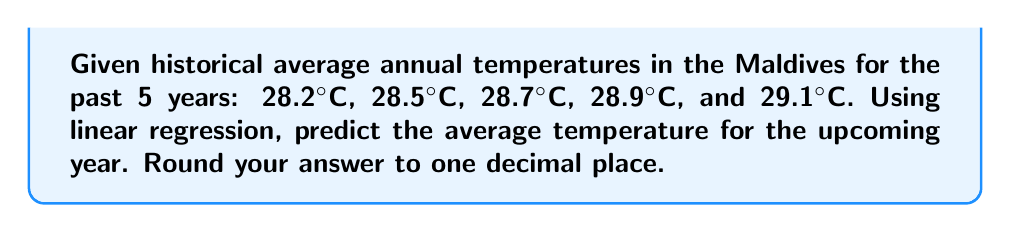Can you answer this question? To predict the future temperature using linear regression, we'll follow these steps:

1. Assign x-values to each year (1, 2, 3, 4, 5) and y-values to the corresponding temperatures.

2. Calculate the means of x and y:
   $\bar{x} = \frac{1+2+3+4+5}{5} = 3$
   $\bar{y} = \frac{28.2+28.5+28.7+28.9+29.1}{5} = 28.68$

3. Calculate the slope (m) using the formula:
   $$m = \frac{\sum(x_i - \bar{x})(y_i - \bar{y})}{\sum(x_i - \bar{x})^2}$$

   $\sum(x_i - \bar{x})(y_i - \bar{y}) = (-2)(-0.48) + (-1)(-0.18) + (0)(0.02) + (1)(0.22) + (2)(0.42) = 1.74$
   $\sum(x_i - \bar{x})^2 = (-2)^2 + (-1)^2 + 0^2 + 1^2 + 2^2 = 10$

   $m = \frac{1.74}{10} = 0.174$

4. Calculate the y-intercept (b) using the formula:
   $b = \bar{y} - m\bar{x} = 28.68 - 0.174(3) = 28.158$

5. The linear regression equation is:
   $y = mx + b = 0.174x + 28.158$

6. To predict the temperature for the upcoming year (x = 6):
   $y = 0.174(6) + 28.158 = 29.202$

7. Rounding to one decimal place: 29.2°C
Answer: 29.2°C 